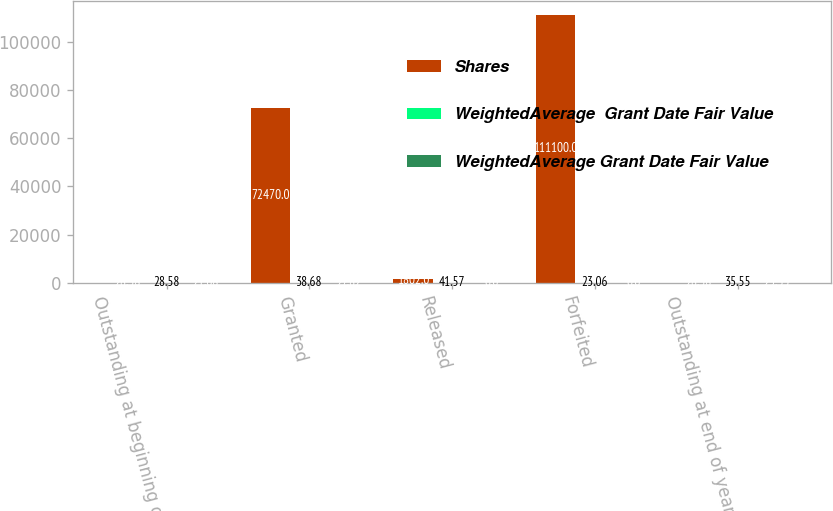Convert chart to OTSL. <chart><loc_0><loc_0><loc_500><loc_500><stacked_bar_chart><ecel><fcel>Outstanding at beginning of<fcel>Granted<fcel>Released<fcel>Forfeited<fcel>Outstanding at end of year<nl><fcel>Shares<fcel>28.58<fcel>72470<fcel>1802<fcel>111100<fcel>28.58<nl><fcel>WeightedAverage  Grant Date Fair Value<fcel>28.58<fcel>38.68<fcel>41.57<fcel>23.06<fcel>35.55<nl><fcel>WeightedAverage Grant Date Fair Value<fcel>21.68<fcel>27.82<fcel>0<fcel>0<fcel>25.35<nl></chart> 